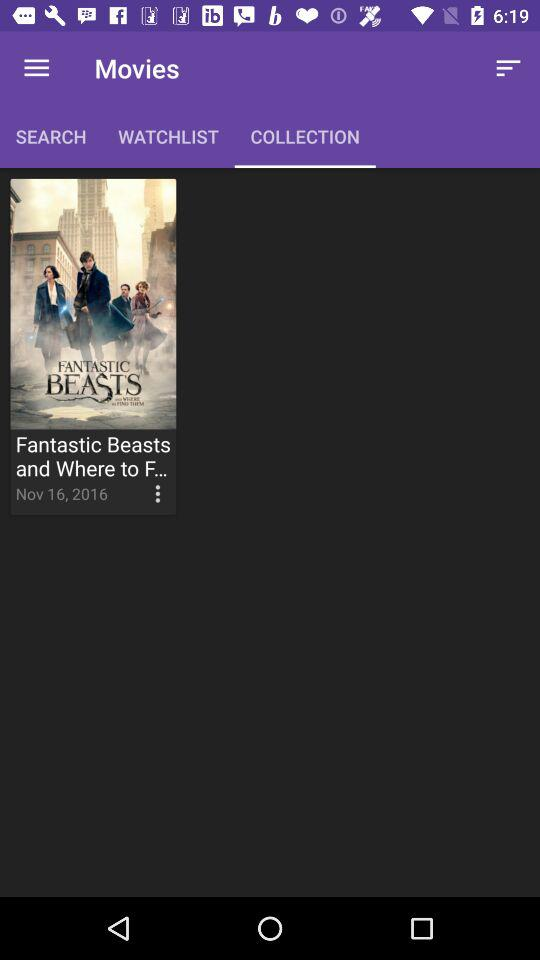How many movies are in "SEARCH"?
When the provided information is insufficient, respond with <no answer>. <no answer> 